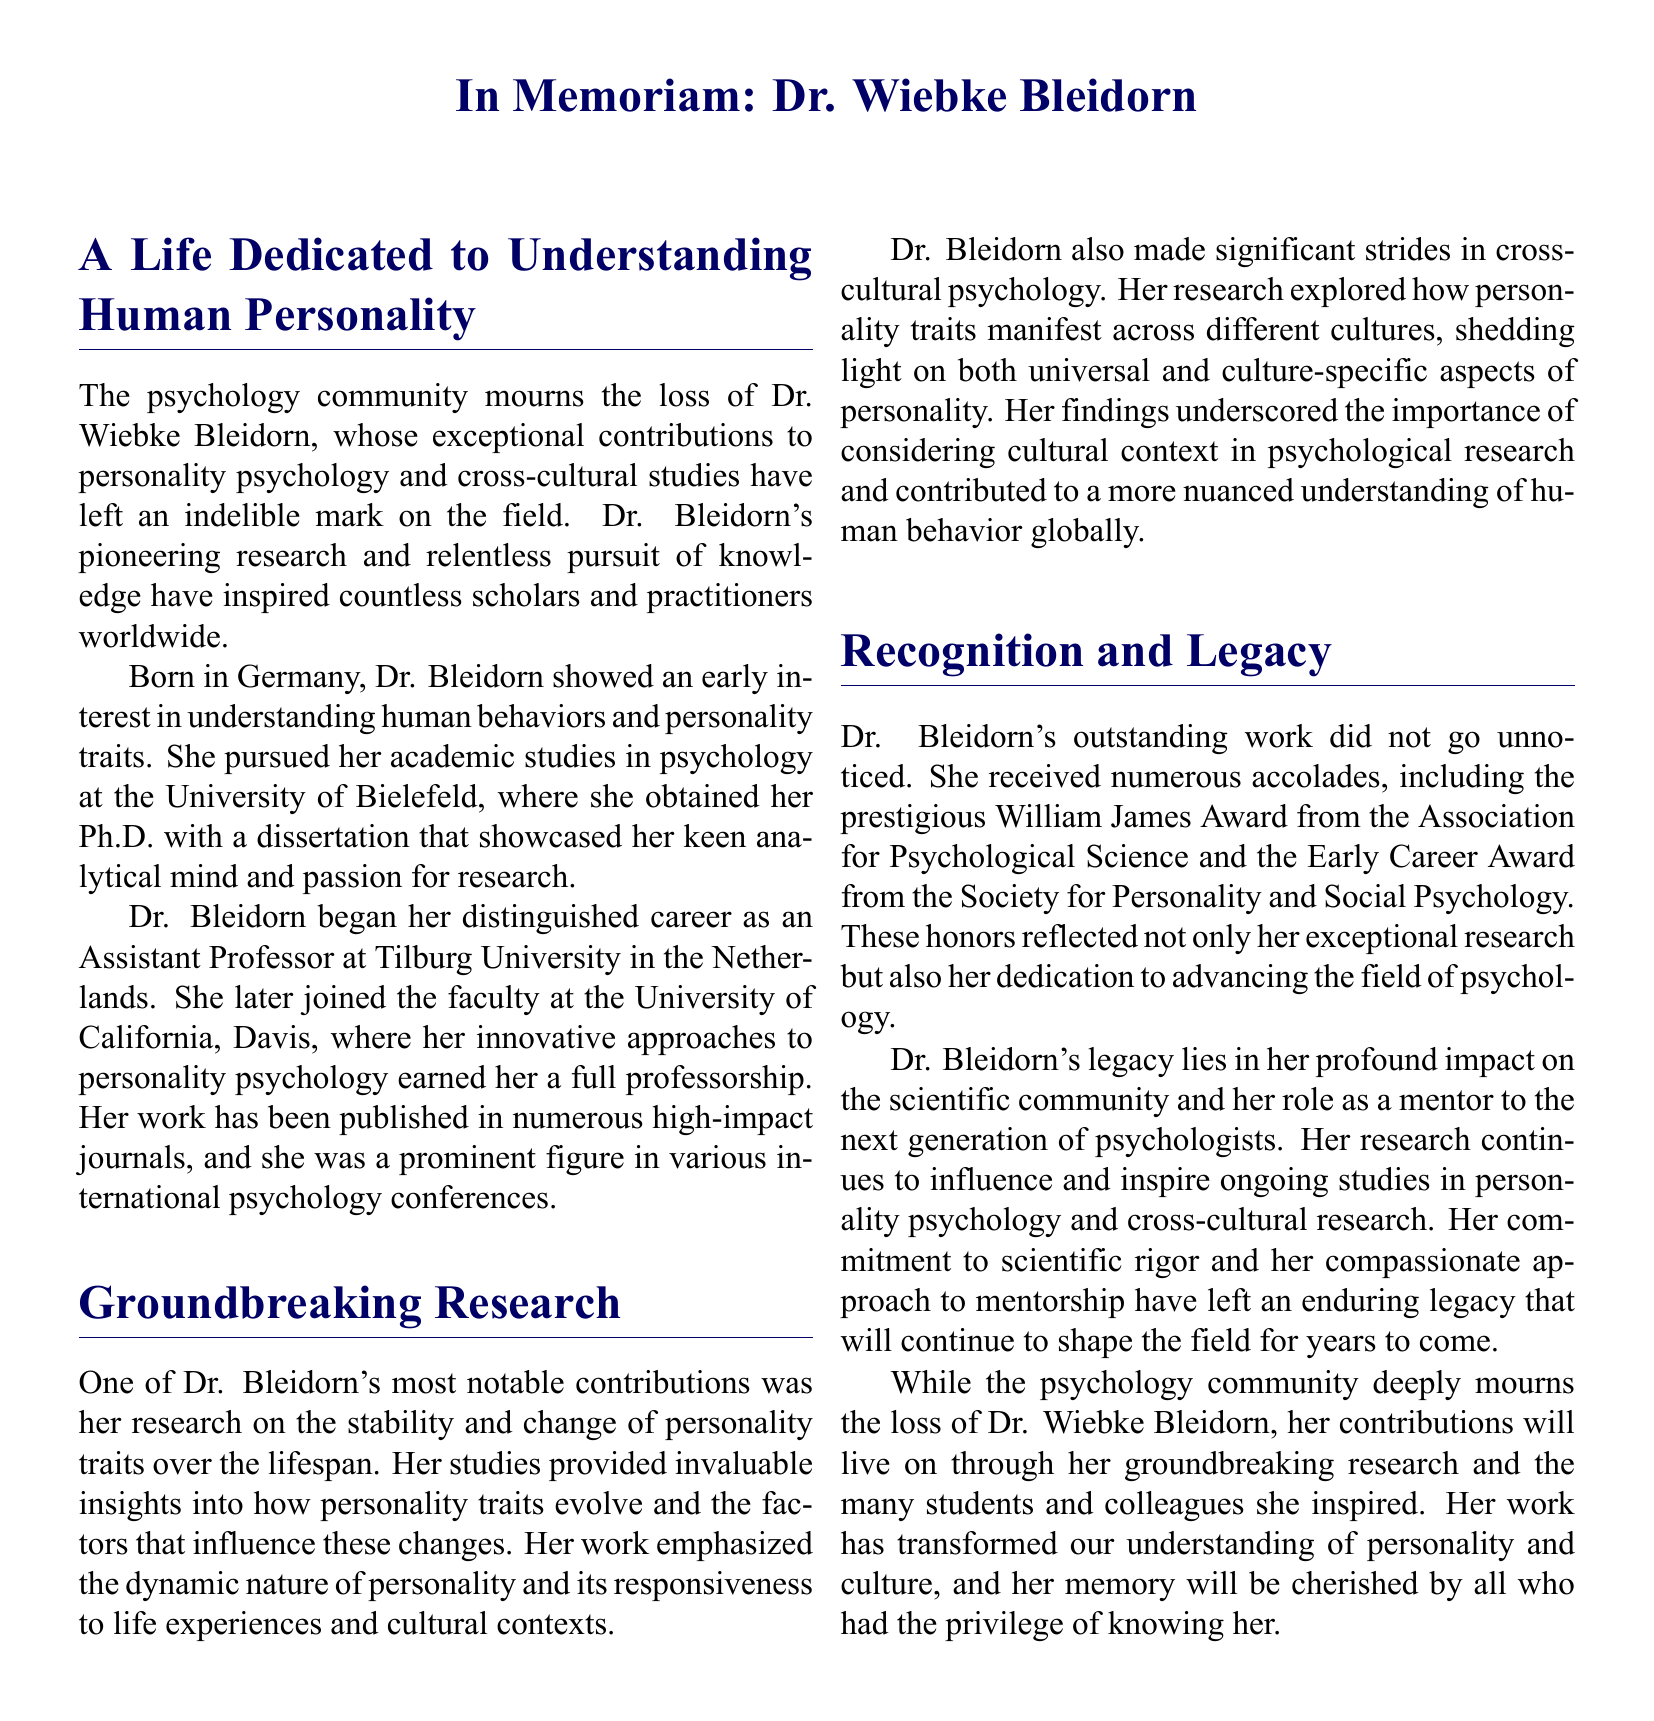What field did Dr. Wiebke Bleidorn contribute to? The document highlights Dr. Bleidorn's exceptional contributions to personality psychology and cross-cultural studies.
Answer: Personality psychology Where was Dr. Bleidorn born? The document mentions that Dr. Bleidorn was born in Germany.
Answer: Germany What was the title of the award Dr. Bleidorn received from the Association for Psychological Science? The document states she received the prestigious William James Award.
Answer: William James Award Which university did Dr. Bleidorn join after Tilburg University? The document indicates that she later joined the University of California, Davis.
Answer: University of California, Davis What did Dr. Bleidorn's research emphasize about personality traits? The document explains that her research emphasized the dynamic nature of personality and its responsiveness to life experiences and cultural contexts.
Answer: Dynamic nature and responsiveness What notable honor is mentioned that Dr. Bleidorn received from the Society for Personality and Social Psychology? The document refers to the Early Career Award as the notable honor from the Society.
Answer: Early Career Award What impact did Dr. Bleidorn have on the scientific community? The document states that her legacy lies in her profound impact on the scientific community and her role as a mentor.
Answer: Profound impact and mentorship What is a primary theme of Dr. Bleidorn's work in cross-cultural psychology? The document highlights her exploration of how personality traits manifest across different cultures, emphasizing cultural context.
Answer: Cultural context in personality traits How did Dr. Bleidorn's research influence ongoing studies in psychology? The document notes that her research continues to influence and inspire ongoing studies in personality psychology and cross-cultural research.
Answer: Influence and inspiration in ongoing studies 